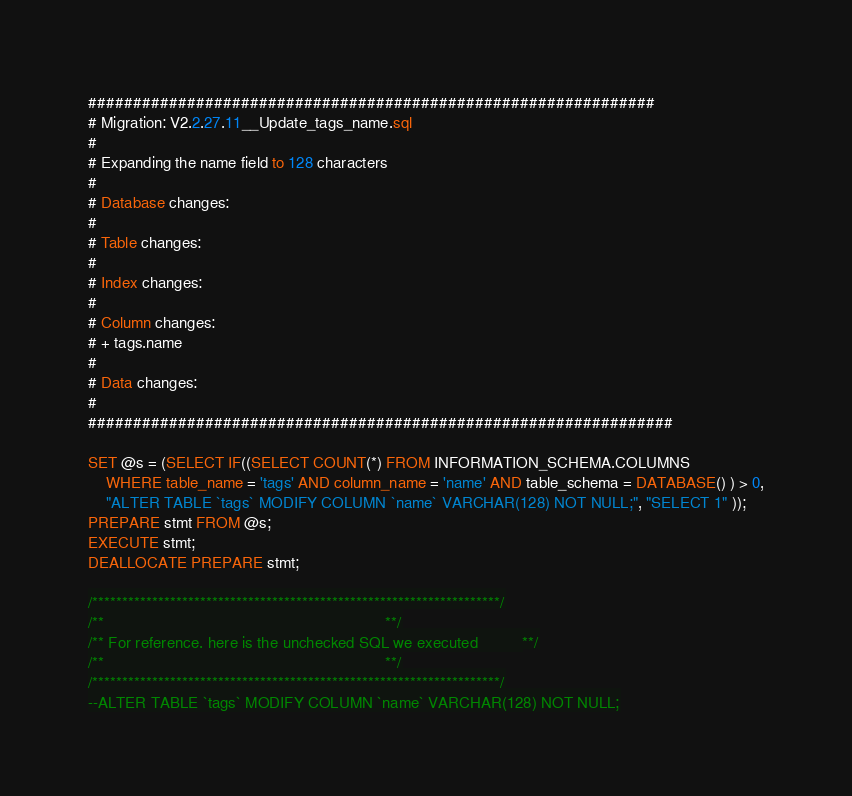Convert code to text. <code><loc_0><loc_0><loc_500><loc_500><_SQL_>###############################################################
# Migration: V2.2.27.11__Update_tags_name.sql
#
# Expanding the name field to 128 characters
# 									   
# Database changes:
#
# Table changes:
#
# Index changes:
# 
# Column changes:
# + tags.name
#
# Data changes:
#
#################################################################

SET @s = (SELECT IF((SELECT COUNT(*) FROM INFORMATION_SCHEMA.COLUMNS
    WHERE table_name = 'tags' AND column_name = 'name' AND table_schema = DATABASE() ) > 0,
    "ALTER TABLE `tags` MODIFY COLUMN `name` VARCHAR(128) NOT NULL;", "SELECT 1" ));
PREPARE stmt FROM @s; 
EXECUTE stmt; 
DEALLOCATE PREPARE stmt;

/********************************************************************/
/**                                                                **/
/** For reference, here is the unchecked SQL we executed 		   **/
/**                                                                **/
/********************************************************************/    
--ALTER TABLE `tags` MODIFY COLUMN `name` VARCHAR(128) NOT NULL;</code> 